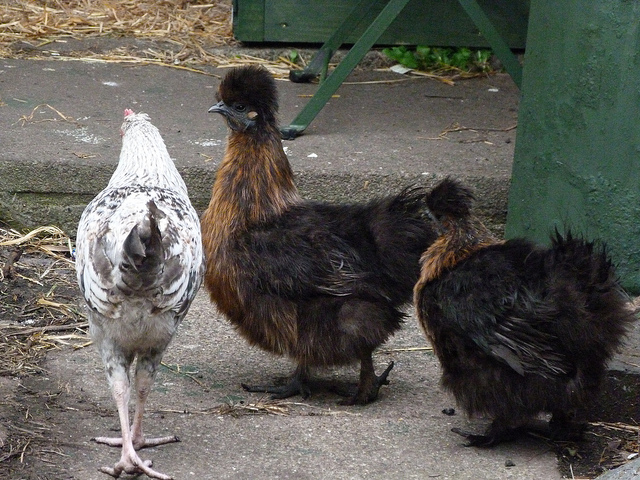<image>Is this a male or female bird? It is unclear whether the bird is male or female. Is this a male or female bird? I don't know if this is a male or female bird. It can be both male and female. 